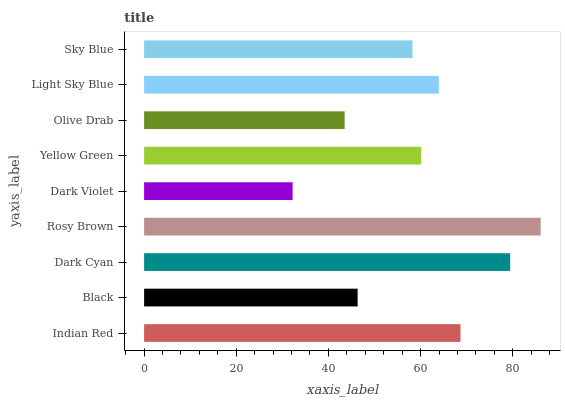Is Dark Violet the minimum?
Answer yes or no. Yes. Is Rosy Brown the maximum?
Answer yes or no. Yes. Is Black the minimum?
Answer yes or no. No. Is Black the maximum?
Answer yes or no. No. Is Indian Red greater than Black?
Answer yes or no. Yes. Is Black less than Indian Red?
Answer yes or no. Yes. Is Black greater than Indian Red?
Answer yes or no. No. Is Indian Red less than Black?
Answer yes or no. No. Is Yellow Green the high median?
Answer yes or no. Yes. Is Yellow Green the low median?
Answer yes or no. Yes. Is Indian Red the high median?
Answer yes or no. No. Is Light Sky Blue the low median?
Answer yes or no. No. 